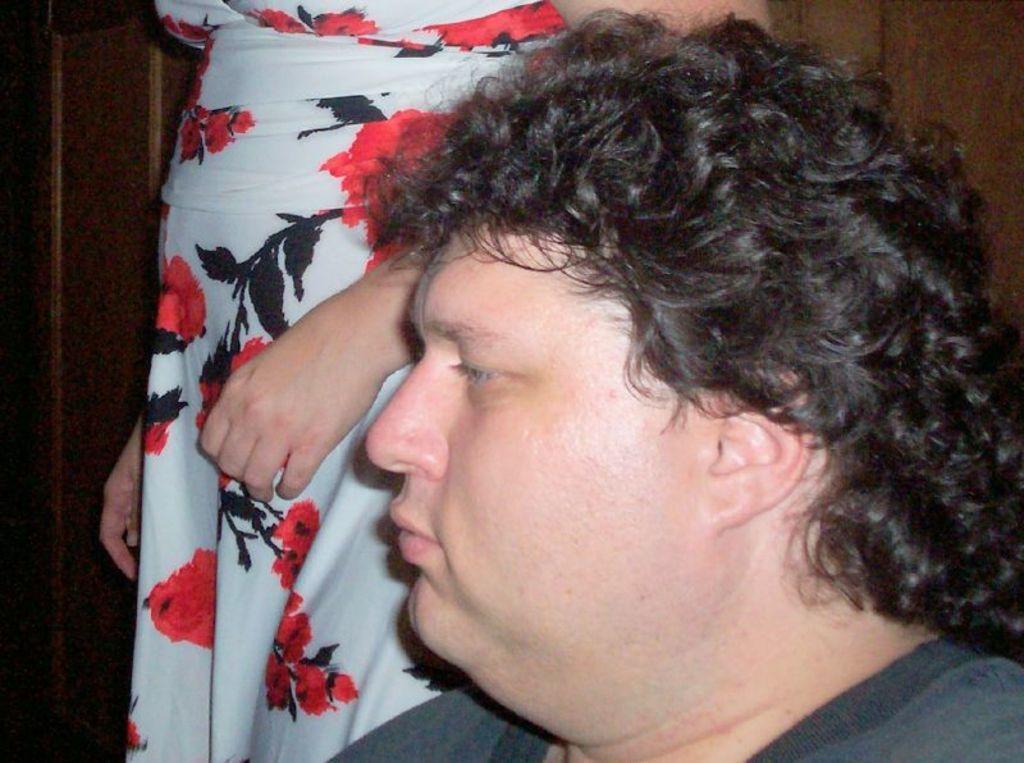Can you describe this image briefly? In this image there is a man. Behind him there is another person standing. In the background there is a wooden wall. 